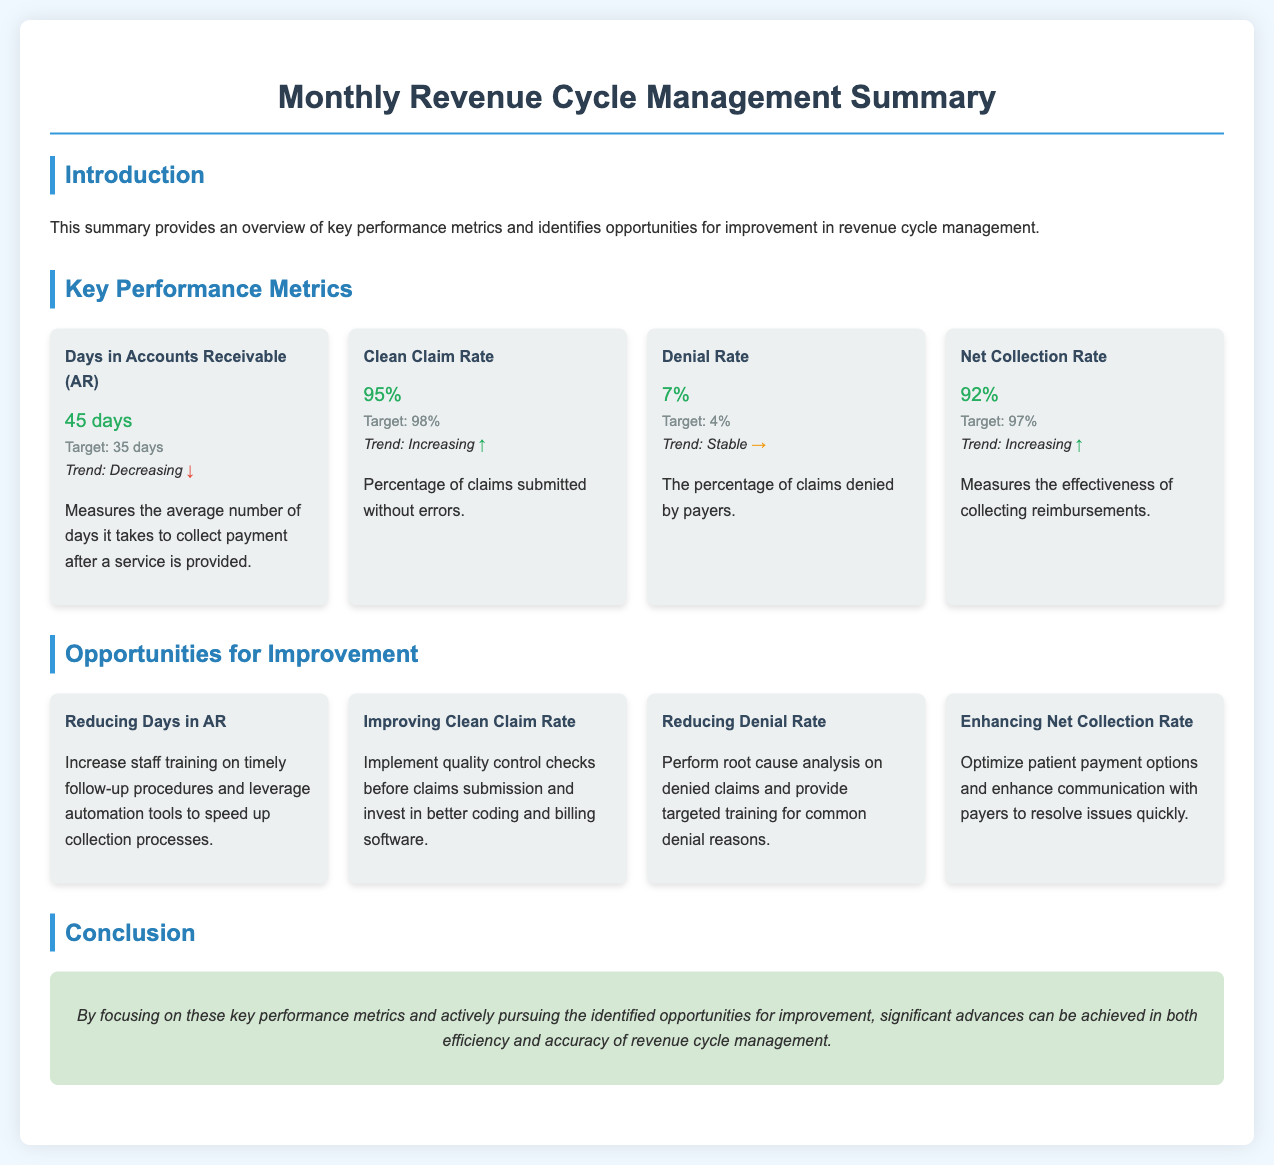what is the average Days in Accounts Receivable? The document states the average Days in Accounts Receivable is 45 days.
Answer: 45 days what is the target for the Clean Claim Rate? The target percentage for the Clean Claim Rate is mentioned as 98%.
Answer: 98% what is the current Denial Rate? The Denial Rate presented in the document is 7%.
Answer: 7% what is one opportunity for improving the Net Collection Rate? The document suggests optimizing patient payment options as an opportunity for improvement.
Answer: Optimize patient payment options what is the trend for the Clean Claim Rate? The trend indicated for the Clean Claim Rate is increasing.
Answer: Increasing what is the target for Days in Accounts Receivable? The target for Days in Accounts Receivable is specified as 35 days.
Answer: 35 days what is being measured by the Net Collection Rate? The Net Collection Rate measures the effectiveness of collecting reimbursements.
Answer: Effectiveness of collecting reimbursements how can the Denial Rate be reduced according to the document? The document recommends performing root cause analysis on denied claims as a method to reduce the Denial Rate.
Answer: Perform root cause analysis on denied claims what is the main conclusion from the summary? The conclusion states that focusing on key performance metrics can lead to significant advances in efficiency and accuracy.
Answer: Focus on key performance metrics for significant advances 